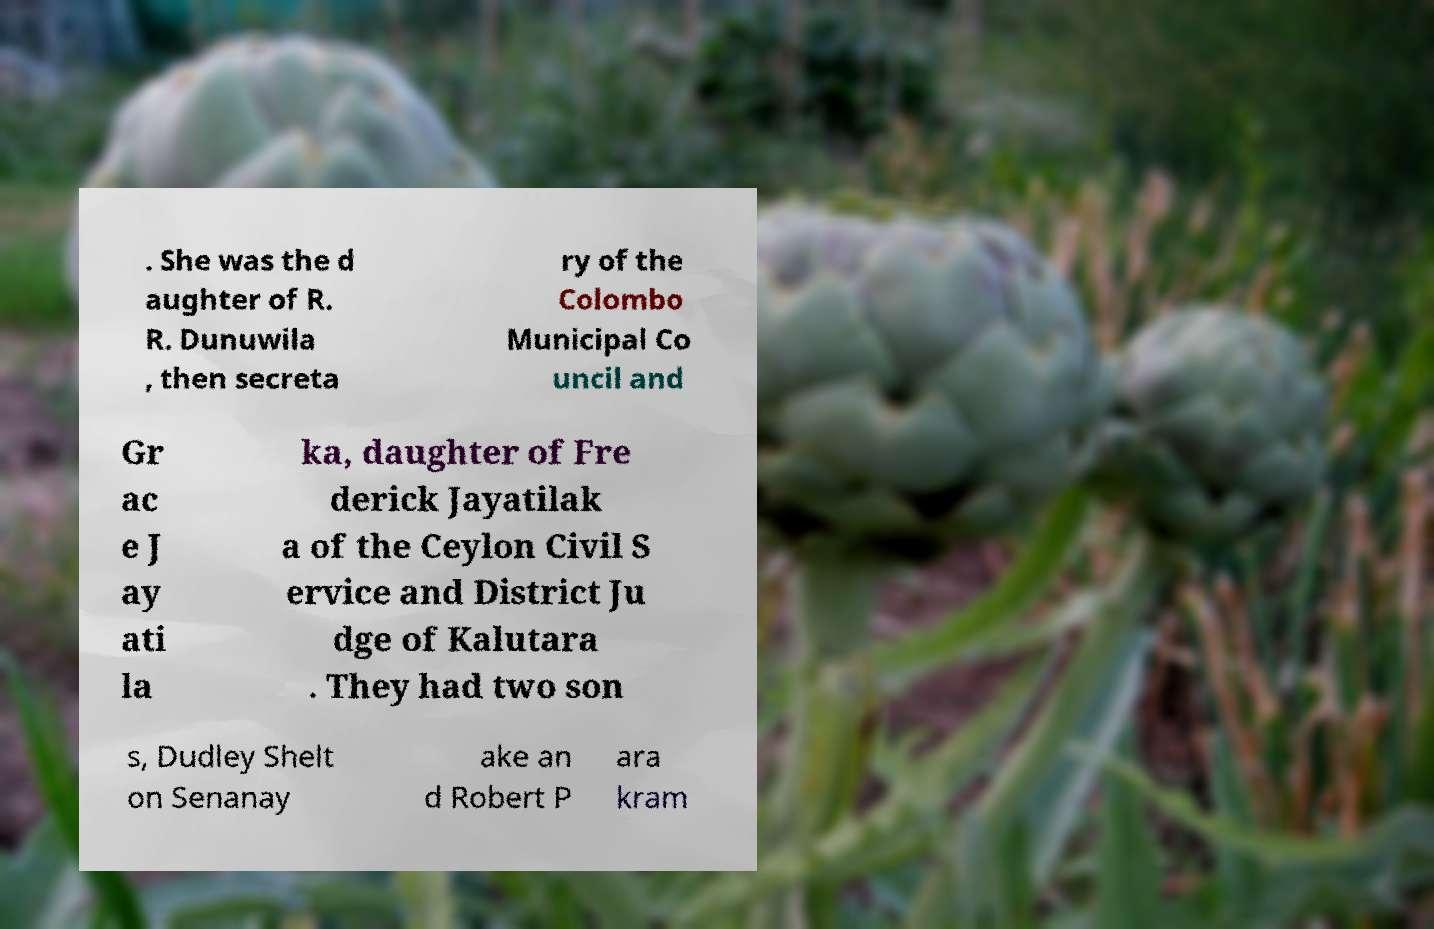Please identify and transcribe the text found in this image. . She was the d aughter of R. R. Dunuwila , then secreta ry of the Colombo Municipal Co uncil and Gr ac e J ay ati la ka, daughter of Fre derick Jayatilak a of the Ceylon Civil S ervice and District Ju dge of Kalutara . They had two son s, Dudley Shelt on Senanay ake an d Robert P ara kram 